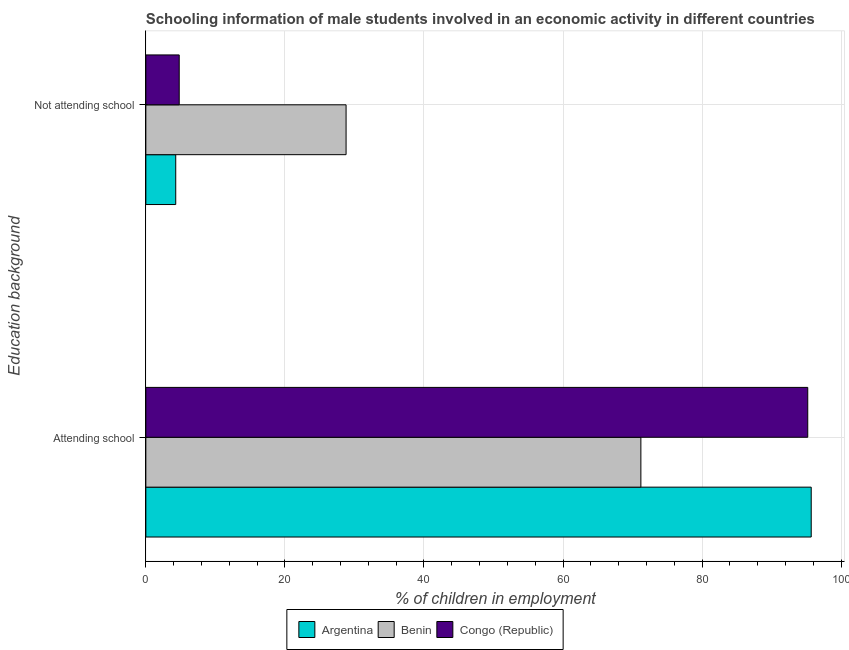How many different coloured bars are there?
Make the answer very short. 3. How many bars are there on the 2nd tick from the bottom?
Your response must be concise. 3. What is the label of the 1st group of bars from the top?
Make the answer very short. Not attending school. Across all countries, what is the maximum percentage of employed males who are not attending school?
Ensure brevity in your answer.  28.8. In which country was the percentage of employed males who are attending school minimum?
Your response must be concise. Benin. What is the total percentage of employed males who are attending school in the graph?
Offer a terse response. 262.1. What is the difference between the percentage of employed males who are attending school in Benin and that in Congo (Republic)?
Ensure brevity in your answer.  -24. What is the difference between the percentage of employed males who are not attending school in Congo (Republic) and the percentage of employed males who are attending school in Argentina?
Your response must be concise. -90.9. What is the average percentage of employed males who are attending school per country?
Keep it short and to the point. 87.37. What is the difference between the percentage of employed males who are not attending school and percentage of employed males who are attending school in Benin?
Your answer should be compact. -42.4. What is the ratio of the percentage of employed males who are not attending school in Benin to that in Argentina?
Offer a very short reply. 6.7. Is the percentage of employed males who are attending school in Argentina less than that in Benin?
Provide a succinct answer. No. In how many countries, is the percentage of employed males who are not attending school greater than the average percentage of employed males who are not attending school taken over all countries?
Provide a short and direct response. 1. What does the 2nd bar from the top in Attending school represents?
Ensure brevity in your answer.  Benin. What does the 3rd bar from the bottom in Attending school represents?
Give a very brief answer. Congo (Republic). How many bars are there?
Offer a very short reply. 6. What is the difference between two consecutive major ticks on the X-axis?
Your answer should be very brief. 20. Does the graph contain any zero values?
Your response must be concise. No. Where does the legend appear in the graph?
Ensure brevity in your answer.  Bottom center. How many legend labels are there?
Your answer should be very brief. 3. How are the legend labels stacked?
Your response must be concise. Horizontal. What is the title of the graph?
Keep it short and to the point. Schooling information of male students involved in an economic activity in different countries. What is the label or title of the X-axis?
Make the answer very short. % of children in employment. What is the label or title of the Y-axis?
Ensure brevity in your answer.  Education background. What is the % of children in employment in Argentina in Attending school?
Your response must be concise. 95.7. What is the % of children in employment of Benin in Attending school?
Provide a short and direct response. 71.2. What is the % of children in employment of Congo (Republic) in Attending school?
Make the answer very short. 95.2. What is the % of children in employment in Argentina in Not attending school?
Your response must be concise. 4.3. What is the % of children in employment in Benin in Not attending school?
Provide a short and direct response. 28.8. What is the % of children in employment of Congo (Republic) in Not attending school?
Make the answer very short. 4.8. Across all Education background, what is the maximum % of children in employment in Argentina?
Provide a succinct answer. 95.7. Across all Education background, what is the maximum % of children in employment of Benin?
Offer a terse response. 71.2. Across all Education background, what is the maximum % of children in employment in Congo (Republic)?
Your answer should be very brief. 95.2. Across all Education background, what is the minimum % of children in employment in Benin?
Offer a terse response. 28.8. Across all Education background, what is the minimum % of children in employment of Congo (Republic)?
Offer a terse response. 4.8. What is the total % of children in employment in Benin in the graph?
Keep it short and to the point. 100. What is the difference between the % of children in employment of Argentina in Attending school and that in Not attending school?
Offer a very short reply. 91.4. What is the difference between the % of children in employment in Benin in Attending school and that in Not attending school?
Ensure brevity in your answer.  42.4. What is the difference between the % of children in employment of Congo (Republic) in Attending school and that in Not attending school?
Your answer should be very brief. 90.4. What is the difference between the % of children in employment of Argentina in Attending school and the % of children in employment of Benin in Not attending school?
Give a very brief answer. 66.9. What is the difference between the % of children in employment of Argentina in Attending school and the % of children in employment of Congo (Republic) in Not attending school?
Offer a very short reply. 90.9. What is the difference between the % of children in employment in Benin in Attending school and the % of children in employment in Congo (Republic) in Not attending school?
Your answer should be very brief. 66.4. What is the difference between the % of children in employment in Benin and % of children in employment in Congo (Republic) in Attending school?
Your response must be concise. -24. What is the difference between the % of children in employment of Argentina and % of children in employment of Benin in Not attending school?
Ensure brevity in your answer.  -24.5. What is the ratio of the % of children in employment of Argentina in Attending school to that in Not attending school?
Your answer should be very brief. 22.26. What is the ratio of the % of children in employment in Benin in Attending school to that in Not attending school?
Provide a short and direct response. 2.47. What is the ratio of the % of children in employment of Congo (Republic) in Attending school to that in Not attending school?
Your answer should be compact. 19.83. What is the difference between the highest and the second highest % of children in employment of Argentina?
Offer a very short reply. 91.4. What is the difference between the highest and the second highest % of children in employment of Benin?
Your answer should be compact. 42.4. What is the difference between the highest and the second highest % of children in employment of Congo (Republic)?
Keep it short and to the point. 90.4. What is the difference between the highest and the lowest % of children in employment in Argentina?
Your answer should be very brief. 91.4. What is the difference between the highest and the lowest % of children in employment of Benin?
Keep it short and to the point. 42.4. What is the difference between the highest and the lowest % of children in employment of Congo (Republic)?
Ensure brevity in your answer.  90.4. 